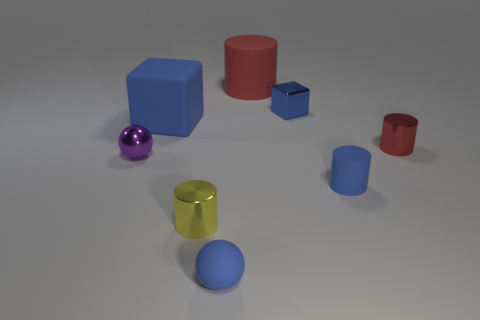There is a matte cube that is the same color as the tiny matte sphere; what is its size?
Your response must be concise. Large. There is a large thing that is the same color as the metallic cube; what shape is it?
Provide a short and direct response. Cube. What color is the big matte thing that is the same shape as the small yellow metal object?
Offer a very short reply. Red. Are there any other things of the same color as the matte block?
Your answer should be very brief. Yes. Do the large rubber cylinder and the tiny cylinder that is behind the small purple ball have the same color?
Offer a terse response. Yes. There is a small ball that is to the right of the blue matte block; does it have the same color as the tiny metal cube?
Give a very brief answer. Yes. Is there a cyan matte cylinder that has the same size as the blue matte cylinder?
Ensure brevity in your answer.  No. How big is the red matte cylinder behind the tiny shiny thing behind the small red thing?
Ensure brevity in your answer.  Large. Is the number of tiny cubes left of the big blue rubber object less than the number of small cubes?
Provide a succinct answer. Yes. Does the shiny block have the same color as the tiny matte cylinder?
Make the answer very short. Yes. 